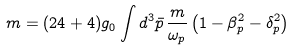<formula> <loc_0><loc_0><loc_500><loc_500>m = ( 2 4 + 4 ) g _ { 0 } \int d ^ { 3 } \bar { p } \, \frac { m } { \omega _ { p } } \left ( 1 - \beta _ { p } ^ { 2 } - \delta _ { p } ^ { 2 } \right )</formula> 